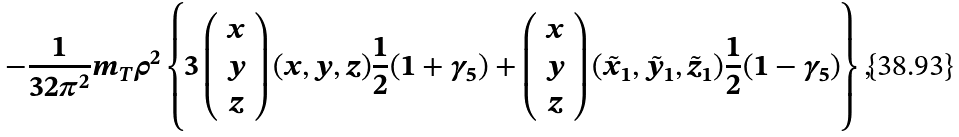Convert formula to latex. <formula><loc_0><loc_0><loc_500><loc_500>- \frac { 1 } { 3 2 \pi ^ { 2 } } m _ { T } \rho ^ { 2 } \left \{ 3 \left ( \begin{array} { c } x \\ y \\ z \end{array} \right ) ( x , y , z ) \frac { 1 } { 2 } ( 1 + \gamma _ { 5 } ) + \left ( \begin{array} { c } x \\ y \\ z \end{array} \right ) ( \tilde { x } _ { 1 } , \tilde { y } _ { 1 } , \tilde { z } _ { 1 } ) \frac { 1 } { 2 } ( 1 - \gamma _ { 5 } ) \right \} ,</formula> 